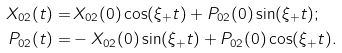<formula> <loc_0><loc_0><loc_500><loc_500>X _ { 0 2 } ( t ) = & \, X _ { 0 2 } ( 0 ) \cos ( \xi _ { + } t ) + P _ { 0 2 } ( 0 ) \sin ( \xi _ { + } t ) ; \\ P _ { 0 2 } ( t ) = & - X _ { 0 2 } ( 0 ) \sin ( \xi _ { + } t ) + P _ { 0 2 } ( 0 ) \cos ( \xi _ { + } t ) .</formula> 